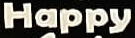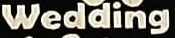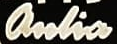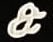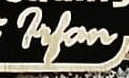Transcribe the words shown in these images in order, separated by a semicolon. Happy; Wedding; anlia; &; Filan 